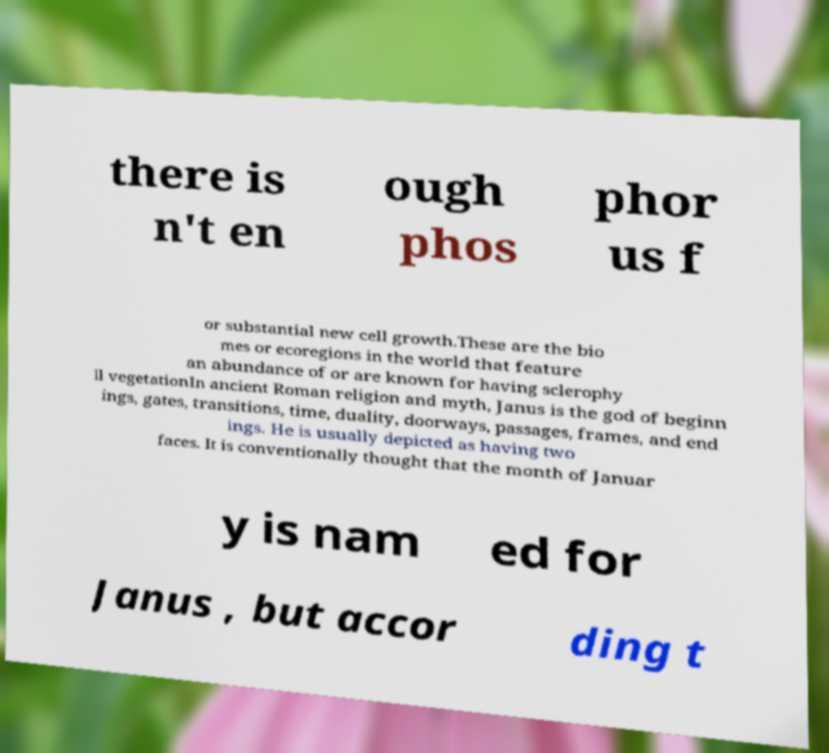There's text embedded in this image that I need extracted. Can you transcribe it verbatim? there is n't en ough phos phor us f or substantial new cell growth.These are the bio mes or ecoregions in the world that feature an abundance of or are known for having sclerophy ll vegetationIn ancient Roman religion and myth, Janus is the god of beginn ings, gates, transitions, time, duality, doorways, passages, frames, and end ings. He is usually depicted as having two faces. It is conventionally thought that the month of Januar y is nam ed for Janus , but accor ding t 